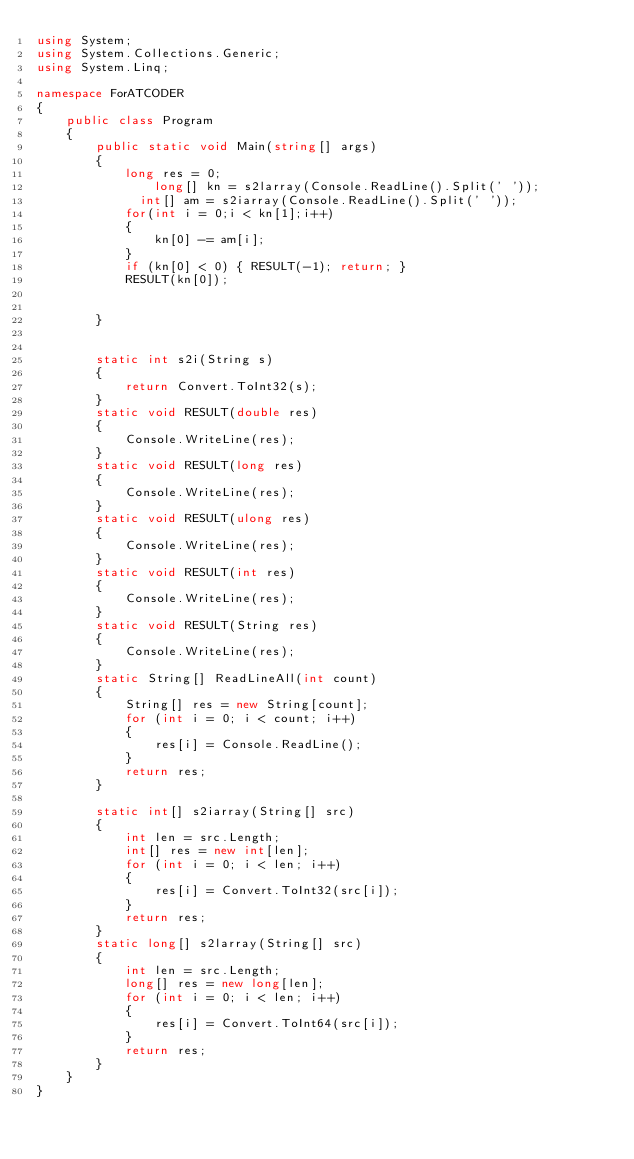Convert code to text. <code><loc_0><loc_0><loc_500><loc_500><_C#_>using System;
using System.Collections.Generic;
using System.Linq;

namespace ForATCODER
{
    public class Program
    {
        public static void Main(string[] args)
        {
            long res = 0;
                long[] kn = s2larray(Console.ReadLine().Split(' '));
              int[] am = s2iarray(Console.ReadLine().Split(' '));
            for(int i = 0;i < kn[1];i++)
            {
                kn[0] -= am[i];
            }
            if (kn[0] < 0) { RESULT(-1); return; }
            RESULT(kn[0]);


        }
      
      
        static int s2i(String s)
        {
            return Convert.ToInt32(s);
        }
        static void RESULT(double res)
        {
            Console.WriteLine(res);
        }
        static void RESULT(long res)
        {
            Console.WriteLine(res);
        }
        static void RESULT(ulong res)
        {
            Console.WriteLine(res);
        }
        static void RESULT(int res)
        {
            Console.WriteLine(res);
        }
        static void RESULT(String res)
        {
            Console.WriteLine(res);
        }
        static String[] ReadLineAll(int count)
        {
            String[] res = new String[count];
            for (int i = 0; i < count; i++)
            {
                res[i] = Console.ReadLine();
            }
            return res;
        }

        static int[] s2iarray(String[] src)
        {
            int len = src.Length;
            int[] res = new int[len];
            for (int i = 0; i < len; i++)
            {
                res[i] = Convert.ToInt32(src[i]);
            }
            return res;
        }
        static long[] s2larray(String[] src)
        {
            int len = src.Length;
            long[] res = new long[len];
            for (int i = 0; i < len; i++)
            {
                res[i] = Convert.ToInt64(src[i]);
            }
            return res;
        }
    }
}
</code> 